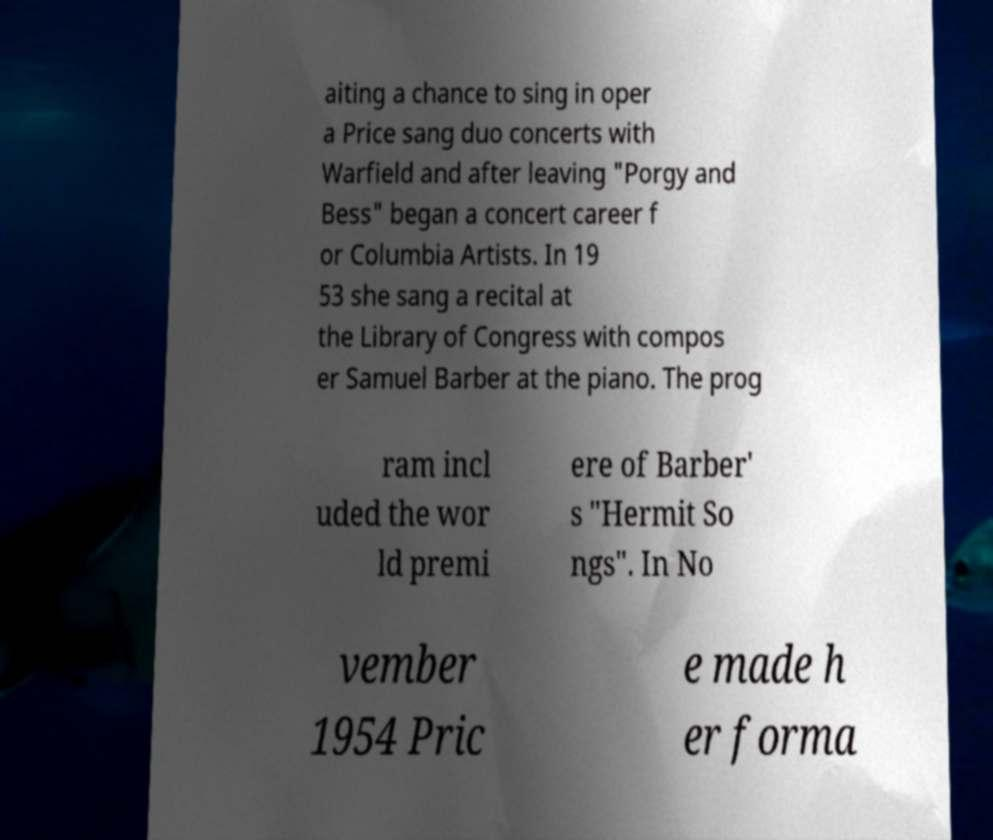Can you accurately transcribe the text from the provided image for me? aiting a chance to sing in oper a Price sang duo concerts with Warfield and after leaving "Porgy and Bess" began a concert career f or Columbia Artists. In 19 53 she sang a recital at the Library of Congress with compos er Samuel Barber at the piano. The prog ram incl uded the wor ld premi ere of Barber' s "Hermit So ngs". In No vember 1954 Pric e made h er forma 